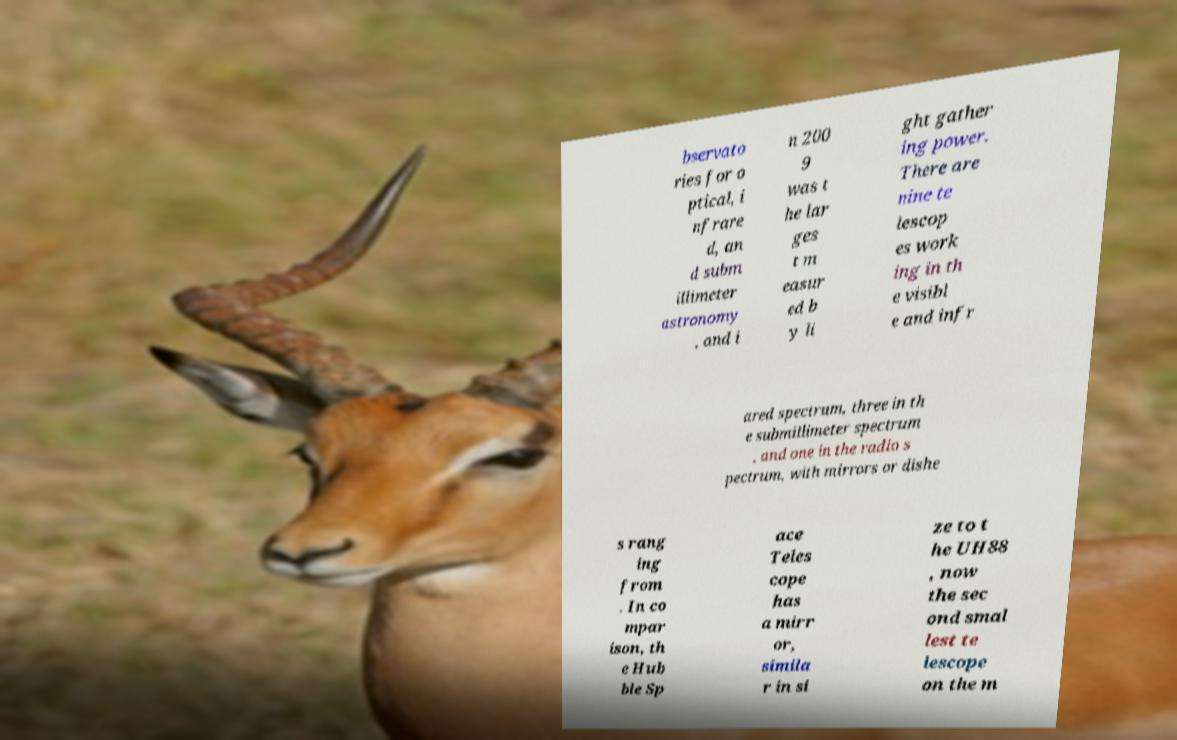Could you extract and type out the text from this image? bservato ries for o ptical, i nfrare d, an d subm illimeter astronomy , and i n 200 9 was t he lar ges t m easur ed b y li ght gather ing power. There are nine te lescop es work ing in th e visibl e and infr ared spectrum, three in th e submillimeter spectrum , and one in the radio s pectrum, with mirrors or dishe s rang ing from . In co mpar ison, th e Hub ble Sp ace Teles cope has a mirr or, simila r in si ze to t he UH88 , now the sec ond smal lest te lescope on the m 